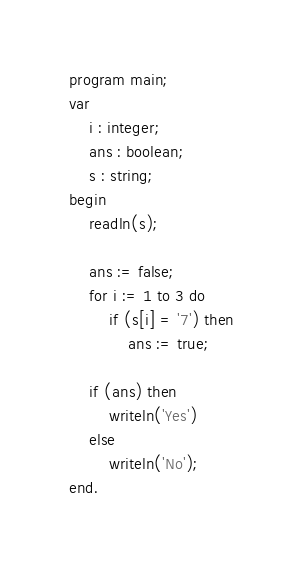<code> <loc_0><loc_0><loc_500><loc_500><_Pascal_>program main;
var
    i : integer;
    ans : boolean;
    s : string;
begin
    readln(s);

    ans := false;
    for i := 1 to 3 do 
        if (s[i] = '7') then
            ans := true;

    if (ans) then
        writeln('Yes')
    else 
        writeln('No');
end.</code> 